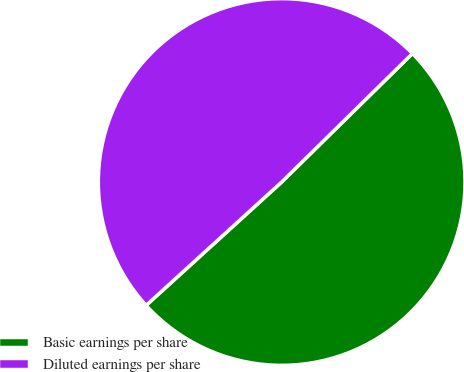Convert chart. <chart><loc_0><loc_0><loc_500><loc_500><pie_chart><fcel>Basic earnings per share<fcel>Diluted earnings per share<nl><fcel>50.61%<fcel>49.39%<nl></chart> 